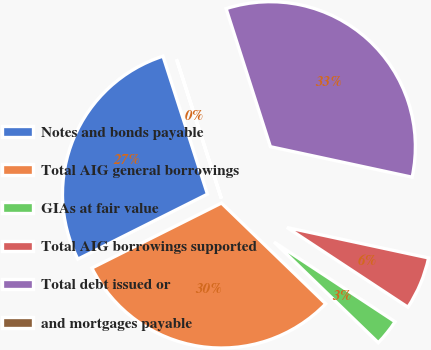<chart> <loc_0><loc_0><loc_500><loc_500><pie_chart><fcel>Notes and bonds payable<fcel>Total AIG general borrowings<fcel>GIAs at fair value<fcel>Total AIG borrowings supported<fcel>Total debt issued or<fcel>and mortgages payable<nl><fcel>27.44%<fcel>30.38%<fcel>2.96%<fcel>5.9%<fcel>33.32%<fcel>0.02%<nl></chart> 